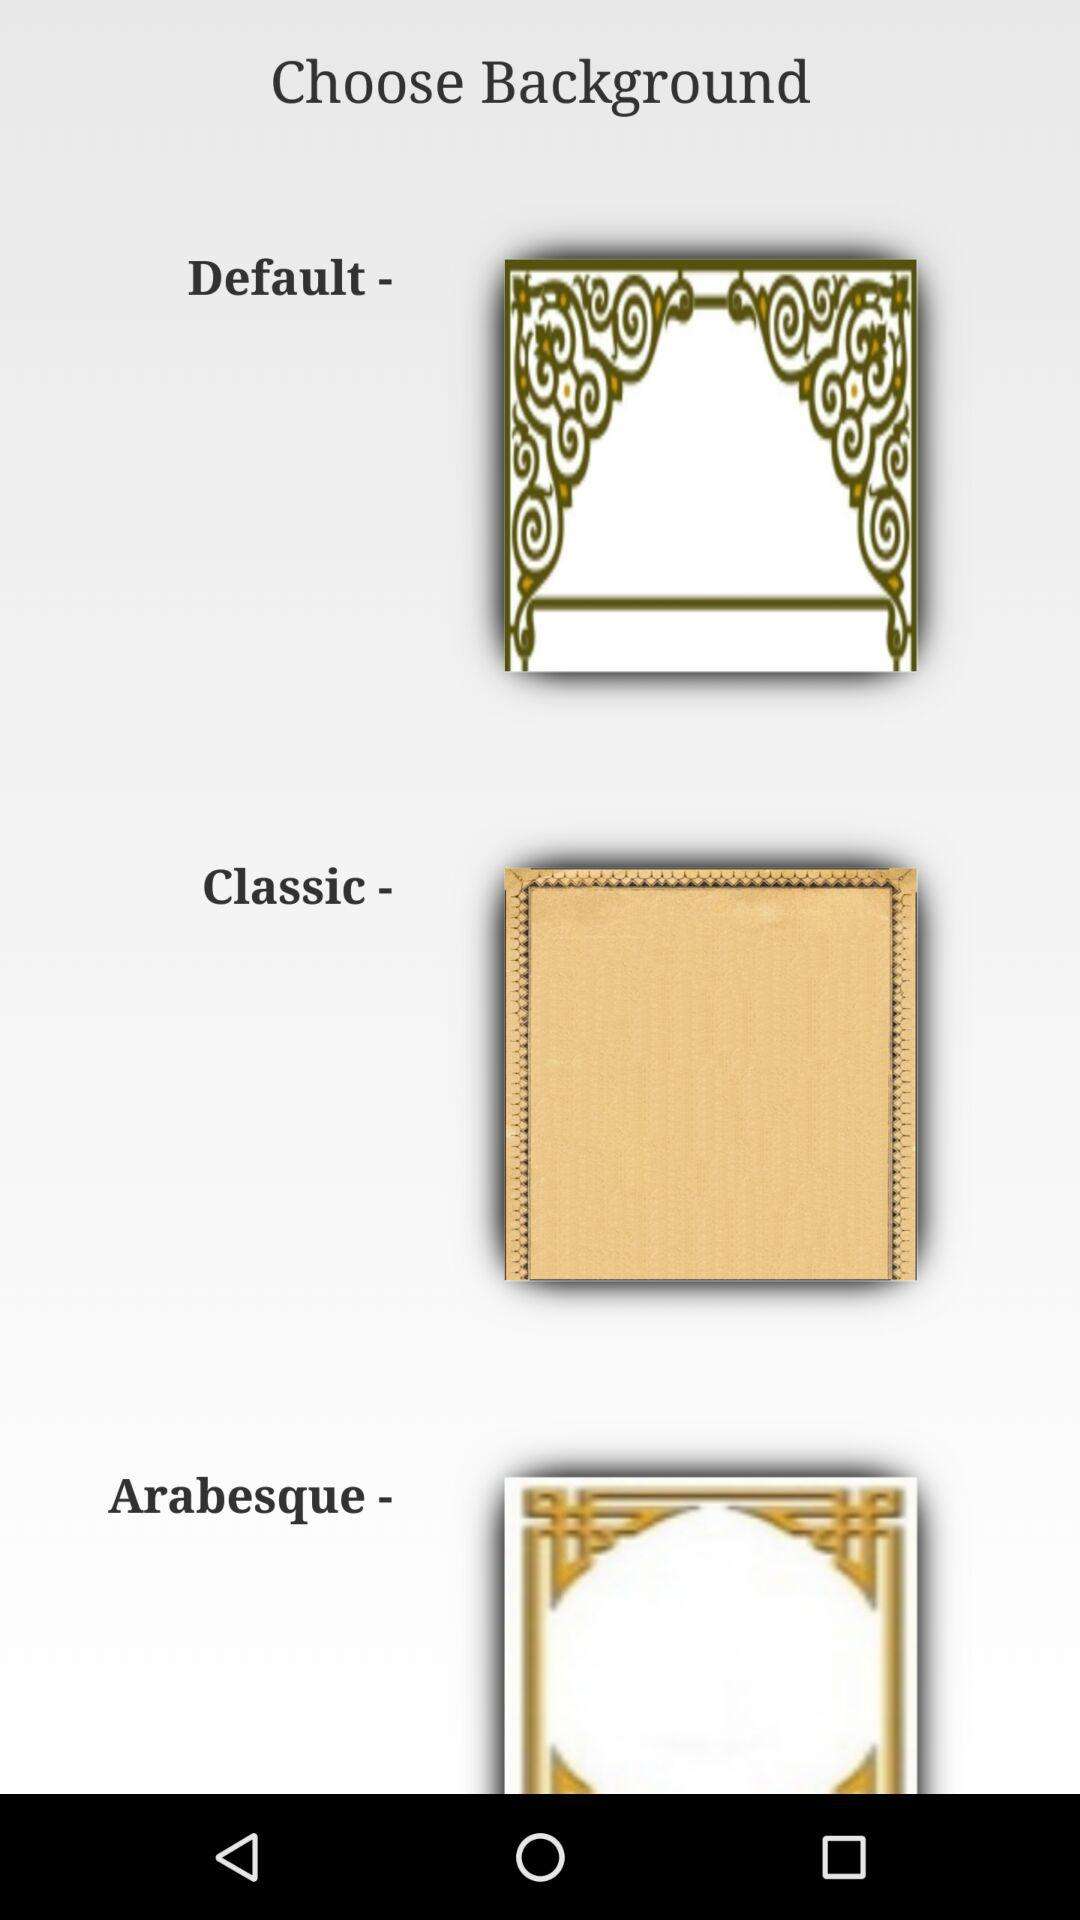What kinds of backgrounds do we have? The kinds of backgrounds that you have are "Default", "Classic" and "Arabesque". 